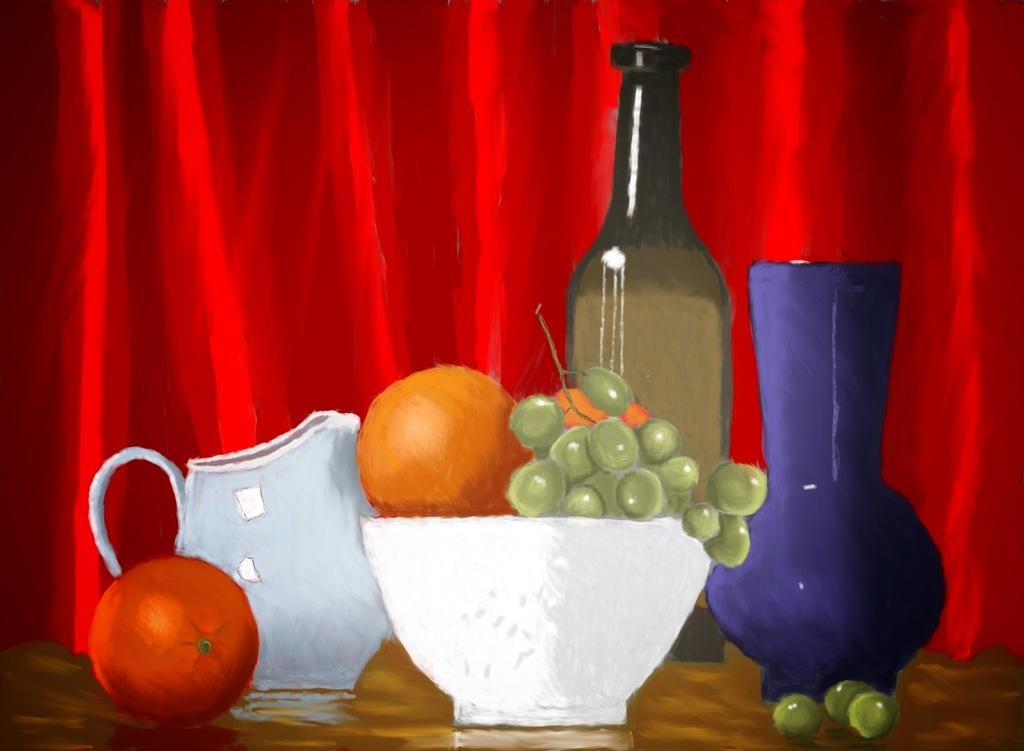What is the main subject of the image? There is a painting in the image. What objects can be seen in the painting? The painting contains a flower vase, a bottle, a bowl of fruits, and a cup. Are there any other elements in the painting besides these objects? Yes, there are fruits on a table and a curtain in the painting. What type of account is being discussed in the painting? There is no account being discussed in the painting; it is a still life painting featuring various objects and elements. Can you see any rocks in the painting? No, there are no rocks present in the painting. 